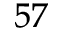<formula> <loc_0><loc_0><loc_500><loc_500>^ { 5 7 }</formula> 